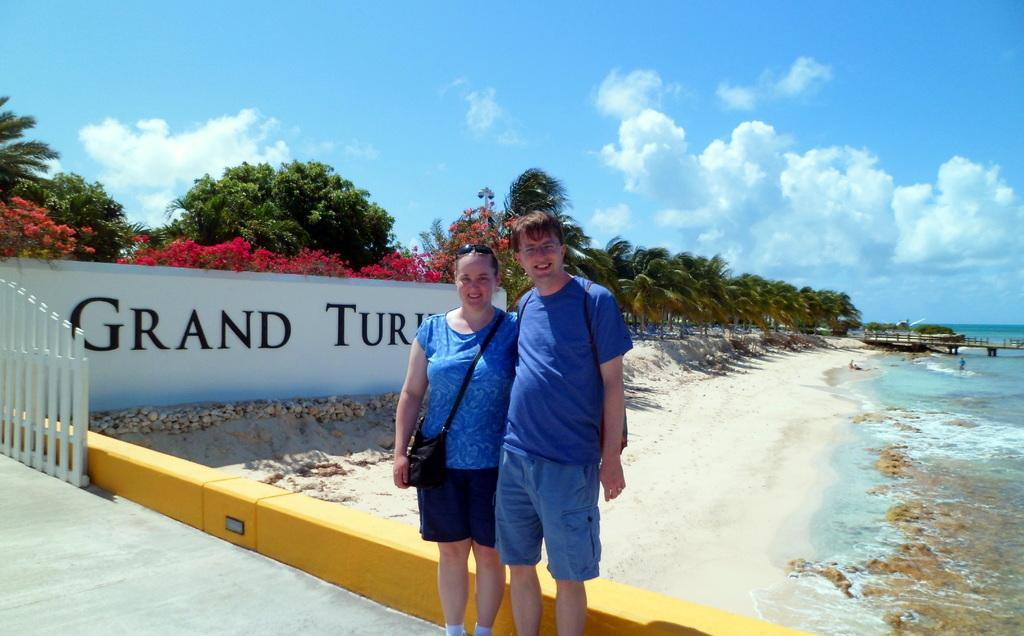What is the main feature of the image? The main feature of the image is water. What structures are present in the image? There is a bridge, a gate, and a wall in the image. What type of vegetation can be seen in the image? There are trees and flowers in the image. How many people are visible in the image? There are two people standing in the front of the image. What is visible at the top of the image? The sky is visible at the top of the image, and there are clouds in the sky. How do the people in the image support the cow? There is no cow present in the image, so the people cannot support a cow. 